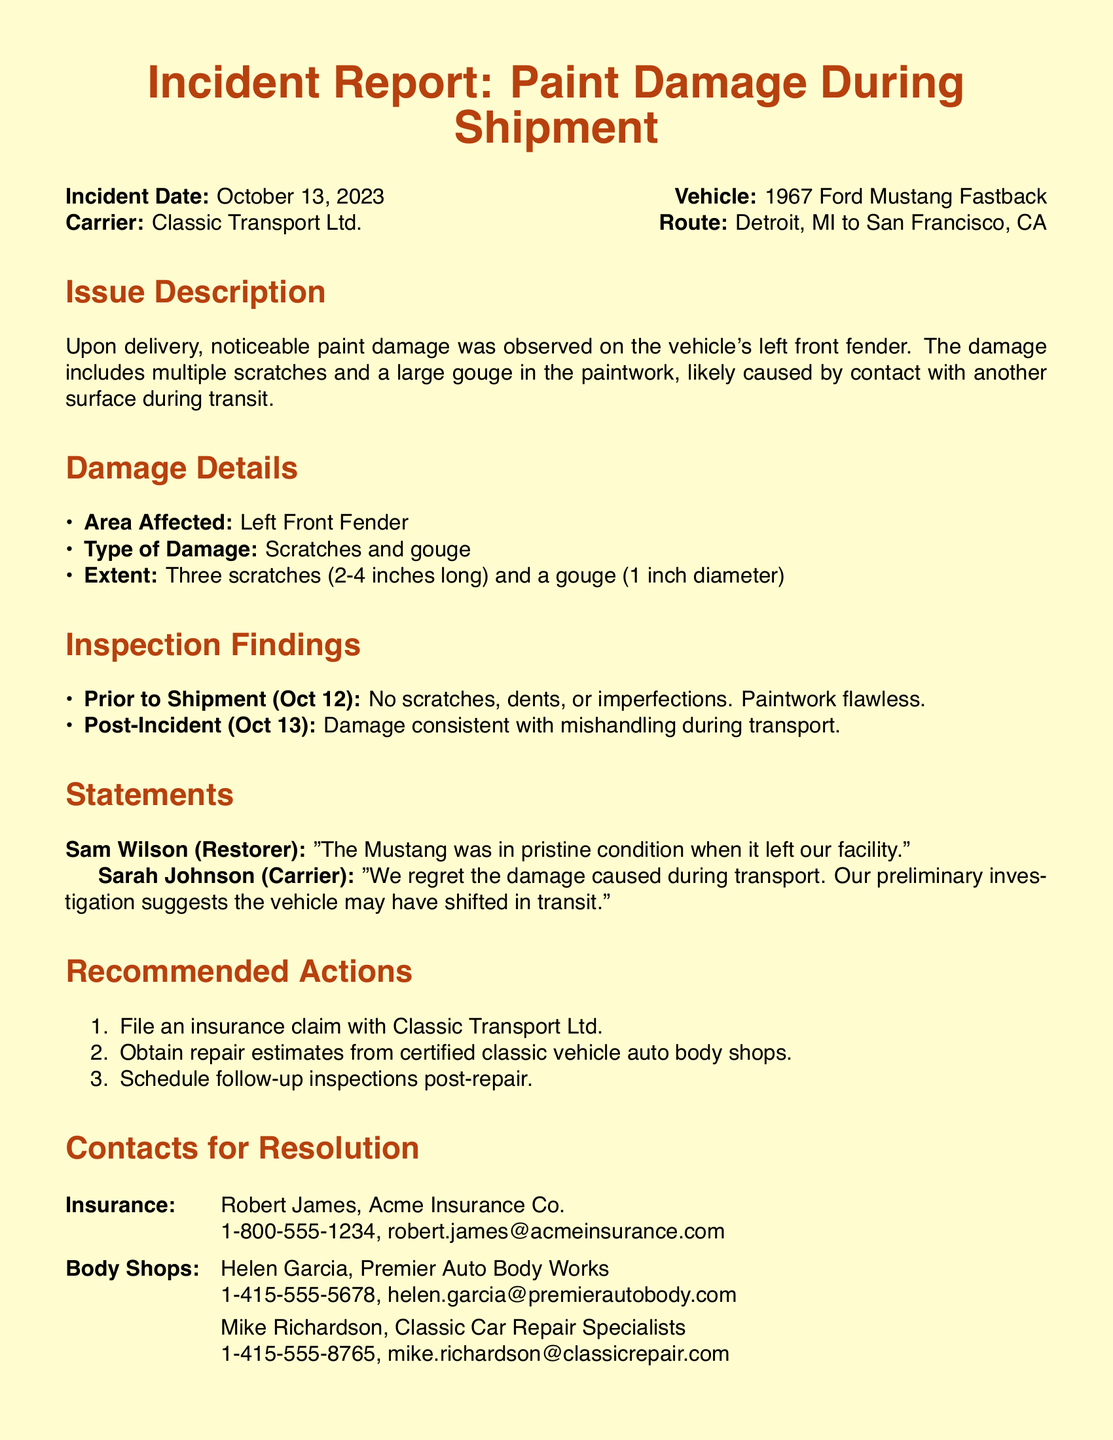what is the incident date? The incident date is mentioned clearly in the report as October 13, 2023.
Answer: October 13, 2023 who is the vehicle carrier? The document specifies the carrier responsible for the transport of the vehicle as Classic Transport Ltd.
Answer: Classic Transport Ltd what type of damage is reported? The report outlines the damage type as scratches and a gouge.
Answer: Scratches and gouge how many scratches were observed? The document states that three scratches were noted on the vehicle.
Answer: Three what was the condition of the vehicle prior to shipment? The report indicates that the paintwork was flawless before shipment.
Answer: Flawless who made a statement about the vehicle's condition? The document includes a statement from Sam Wilson, the restorer.
Answer: Sam Wilson what action is recommended for insurance? The report recommends filing an insurance claim with the carrier.
Answer: File an insurance claim how many people are listed for body shop contacts? The document lists two contacts for body shops.
Answer: Two what was the delivery route for the vehicle? The report details the route taken as from Detroit, MI to San Francisco, CA.
Answer: Detroit, MI to San Francisco, CA what was the extent of the gouge mentioned? The gouge is specified in the document as having a diameter of 1 inch.
Answer: 1 inch diameter 